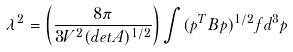Convert formula to latex. <formula><loc_0><loc_0><loc_500><loc_500>\lambda ^ { 2 } = \left ( \frac { 8 \pi } { 3 V ^ { 2 } ( d e t A ) ^ { 1 / 2 } } \right ) \int ( p ^ { T } B p ) ^ { 1 / 2 } f d ^ { 3 } p</formula> 